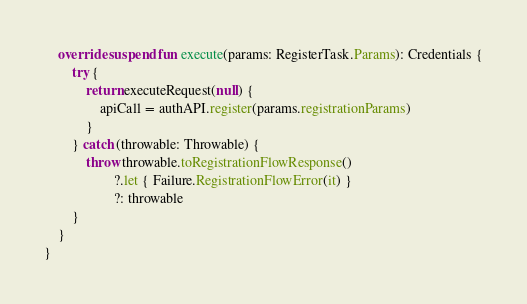Convert code to text. <code><loc_0><loc_0><loc_500><loc_500><_Kotlin_>
    override suspend fun execute(params: RegisterTask.Params): Credentials {
        try {
            return executeRequest(null) {
                apiCall = authAPI.register(params.registrationParams)
            }
        } catch (throwable: Throwable) {
            throw throwable.toRegistrationFlowResponse()
                    ?.let { Failure.RegistrationFlowError(it) }
                    ?: throwable
        }
    }
}
</code> 